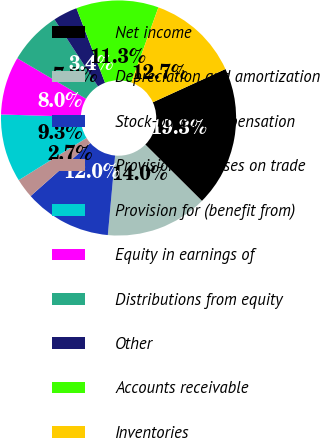<chart> <loc_0><loc_0><loc_500><loc_500><pie_chart><fcel>Net income<fcel>Depreciation and amortization<fcel>Stock-based compensation<fcel>Provision for losses on trade<fcel>Provision for (benefit from)<fcel>Equity in earnings of<fcel>Distributions from equity<fcel>Other<fcel>Accounts receivable<fcel>Inventories<nl><fcel>19.3%<fcel>13.99%<fcel>11.99%<fcel>2.69%<fcel>9.34%<fcel>8.01%<fcel>7.34%<fcel>3.35%<fcel>11.33%<fcel>12.66%<nl></chart> 